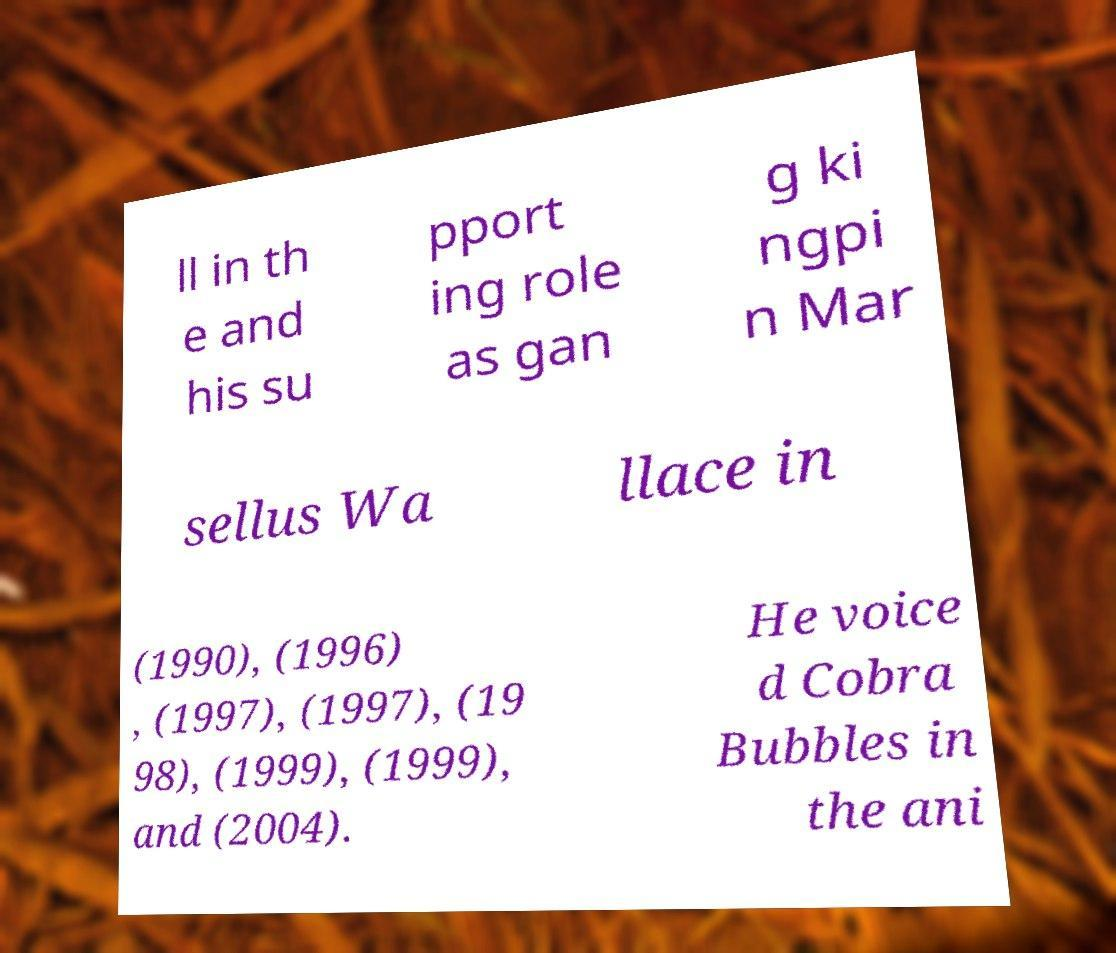There's text embedded in this image that I need extracted. Can you transcribe it verbatim? ll in th e and his su pport ing role as gan g ki ngpi n Mar sellus Wa llace in (1990), (1996) , (1997), (1997), (19 98), (1999), (1999), and (2004). He voice d Cobra Bubbles in the ani 